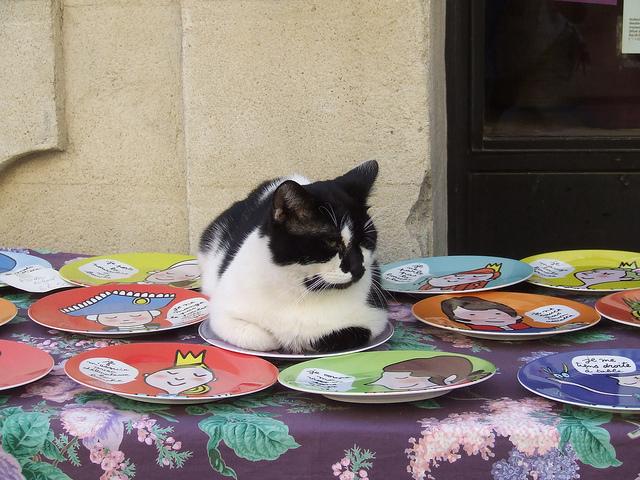How many plates?
Write a very short answer. 13. Where is the cat?
Write a very short answer. On plate. What color is the plate in the front, on the right?
Be succinct. Blue. 